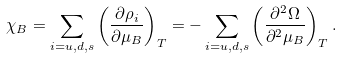Convert formula to latex. <formula><loc_0><loc_0><loc_500><loc_500>\chi _ { B } = \sum _ { i = u , d , s } \left ( \frac { \partial \rho _ { i } } { \partial \mu _ { B } } \right ) _ { T } = - \sum _ { i = u , d , s } \left ( \frac { \partial ^ { 2 } \Omega } { \partial ^ { 2 } \mu _ { B } } \right ) _ { T } .</formula> 